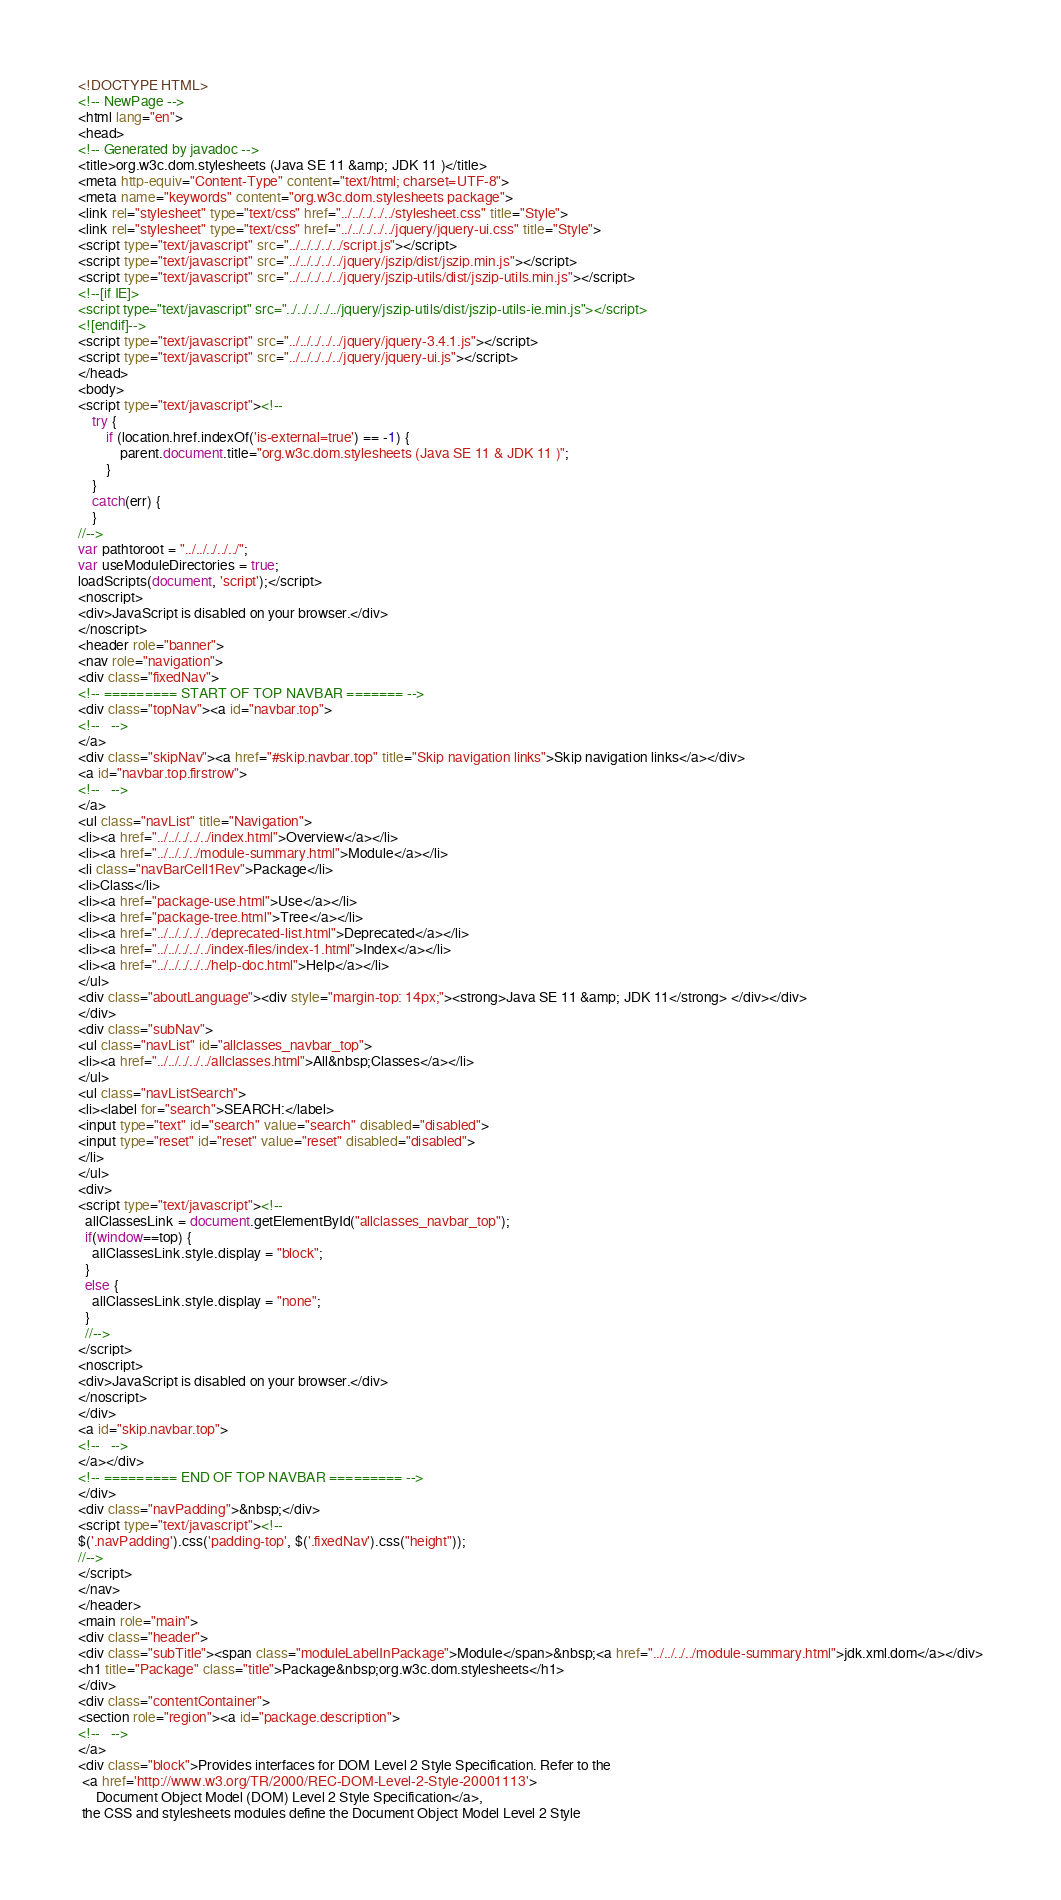<code> <loc_0><loc_0><loc_500><loc_500><_HTML_><!DOCTYPE HTML>
<!-- NewPage -->
<html lang="en">
<head>
<!-- Generated by javadoc -->
<title>org.w3c.dom.stylesheets (Java SE 11 &amp; JDK 11 )</title>
<meta http-equiv="Content-Type" content="text/html; charset=UTF-8">
<meta name="keywords" content="org.w3c.dom.stylesheets package">
<link rel="stylesheet" type="text/css" href="../../../../../stylesheet.css" title="Style">
<link rel="stylesheet" type="text/css" href="../../../../../jquery/jquery-ui.css" title="Style">
<script type="text/javascript" src="../../../../../script.js"></script>
<script type="text/javascript" src="../../../../../jquery/jszip/dist/jszip.min.js"></script>
<script type="text/javascript" src="../../../../../jquery/jszip-utils/dist/jszip-utils.min.js"></script>
<!--[if IE]>
<script type="text/javascript" src="../../../../../jquery/jszip-utils/dist/jszip-utils-ie.min.js"></script>
<![endif]-->
<script type="text/javascript" src="../../../../../jquery/jquery-3.4.1.js"></script>
<script type="text/javascript" src="../../../../../jquery/jquery-ui.js"></script>
</head>
<body>
<script type="text/javascript"><!--
    try {
        if (location.href.indexOf('is-external=true') == -1) {
            parent.document.title="org.w3c.dom.stylesheets (Java SE 11 & JDK 11 )";
        }
    }
    catch(err) {
    }
//-->
var pathtoroot = "../../../../../";
var useModuleDirectories = true;
loadScripts(document, 'script');</script>
<noscript>
<div>JavaScript is disabled on your browser.</div>
</noscript>
<header role="banner">
<nav role="navigation">
<div class="fixedNav">
<!-- ========= START OF TOP NAVBAR ======= -->
<div class="topNav"><a id="navbar.top">
<!--   -->
</a>
<div class="skipNav"><a href="#skip.navbar.top" title="Skip navigation links">Skip navigation links</a></div>
<a id="navbar.top.firstrow">
<!--   -->
</a>
<ul class="navList" title="Navigation">
<li><a href="../../../../../index.html">Overview</a></li>
<li><a href="../../../../module-summary.html">Module</a></li>
<li class="navBarCell1Rev">Package</li>
<li>Class</li>
<li><a href="package-use.html">Use</a></li>
<li><a href="package-tree.html">Tree</a></li>
<li><a href="../../../../../deprecated-list.html">Deprecated</a></li>
<li><a href="../../../../../index-files/index-1.html">Index</a></li>
<li><a href="../../../../../help-doc.html">Help</a></li>
</ul>
<div class="aboutLanguage"><div style="margin-top: 14px;"><strong>Java SE 11 &amp; JDK 11</strong> </div></div>
</div>
<div class="subNav">
<ul class="navList" id="allclasses_navbar_top">
<li><a href="../../../../../allclasses.html">All&nbsp;Classes</a></li>
</ul>
<ul class="navListSearch">
<li><label for="search">SEARCH:</label>
<input type="text" id="search" value="search" disabled="disabled">
<input type="reset" id="reset" value="reset" disabled="disabled">
</li>
</ul>
<div>
<script type="text/javascript"><!--
  allClassesLink = document.getElementById("allclasses_navbar_top");
  if(window==top) {
    allClassesLink.style.display = "block";
  }
  else {
    allClassesLink.style.display = "none";
  }
  //-->
</script>
<noscript>
<div>JavaScript is disabled on your browser.</div>
</noscript>
</div>
<a id="skip.navbar.top">
<!--   -->
</a></div>
<!-- ========= END OF TOP NAVBAR ========= -->
</div>
<div class="navPadding">&nbsp;</div>
<script type="text/javascript"><!--
$('.navPadding').css('padding-top', $('.fixedNav').css("height"));
//-->
</script>
</nav>
</header>
<main role="main">
<div class="header">
<div class="subTitle"><span class="moduleLabelInPackage">Module</span>&nbsp;<a href="../../../../module-summary.html">jdk.xml.dom</a></div>
<h1 title="Package" class="title">Package&nbsp;org.w3c.dom.stylesheets</h1>
</div>
<div class="contentContainer">
<section role="region"><a id="package.description">
<!--   -->
</a>
<div class="block">Provides interfaces for DOM Level 2 Style Specification. Refer to the
 <a href='http://www.w3.org/TR/2000/REC-DOM-Level-2-Style-20001113'>
     Document Object Model (DOM) Level 2 Style Specification</a>,
 the CSS and stylesheets modules define the Document Object Model Level 2 Style</code> 